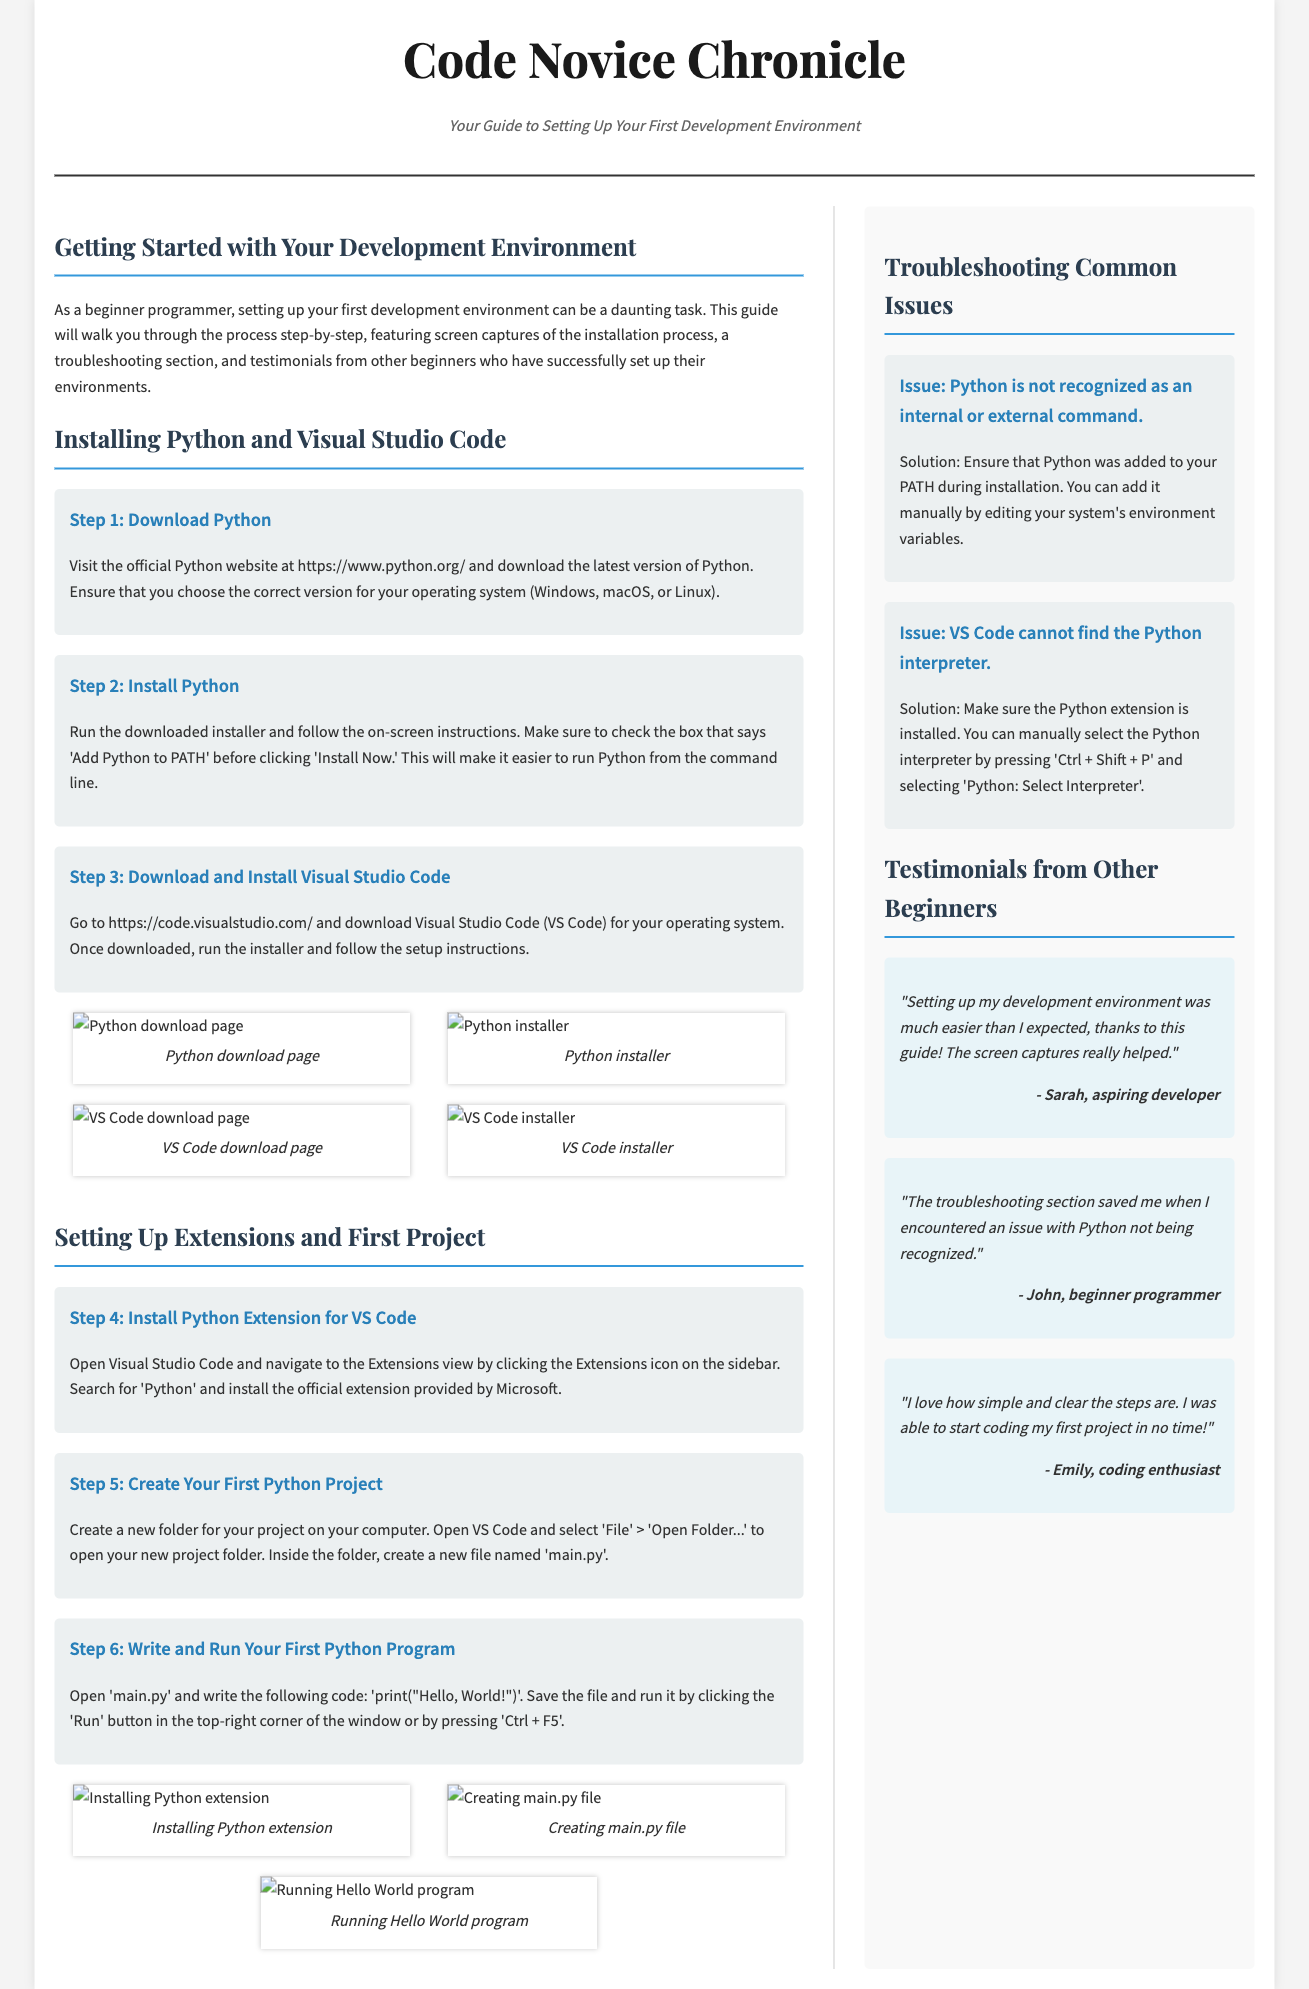What is the title of the article? The title is prominently displayed at the top of the document, indicating the focus of the article.
Answer: Code Novice Chronicle What is the subtitle of the guide? The subtitle is located just below the title and summarizes the purpose of the guide.
Answer: Your Guide to Setting Up Your First Development Environment How many steps are provided for installing Python and Visual Studio Code? The document lists a total of six steps for setting up the development environment, which includes both Python and VS Code installation processes.
Answer: Six What issue is mentioned related to Python not being recognized? This specific issue is outlined in the troubleshooting section, indicating a common problem faced by beginners.
Answer: Python is not recognized as an internal or external command Which extension is recommended for VS Code? The document emphasizes the installation of a specific extension essential for Python programming within Visual Studio Code.
Answer: Python Extension Who provided a testimonial about the troubleshooting section? The testimonials include feedback from various individuals who found the guide helpful, focusing on specific aspects like troubleshooting.
Answer: John What action should you take if VS Code cannot find the Python interpreter? The solution provided in the troubleshooting section suggests an action to resolve this problem.
Answer: Select Interpreter How did Sarah describe her experience setting up a development environment? The testimonials section contains her feedback and highlights her perspective on the installation process.
Answer: Much easier than expected 